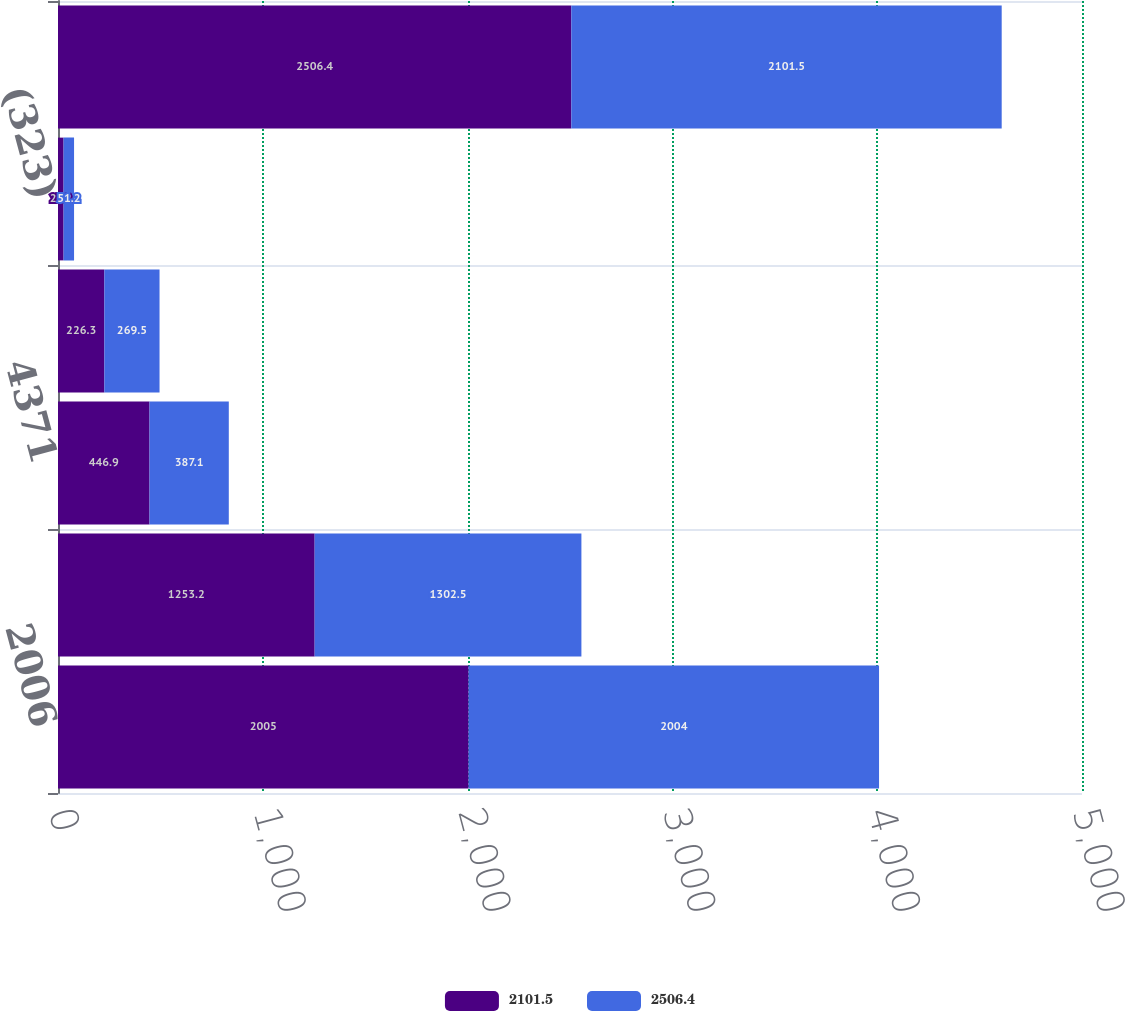<chart> <loc_0><loc_0><loc_500><loc_500><stacked_bar_chart><ecel><fcel>2006<fcel>12422<fcel>4371<fcel>2462<fcel>(323)<fcel>23106<nl><fcel>2101.5<fcel>2005<fcel>1253.2<fcel>446.9<fcel>226.3<fcel>27.2<fcel>2506.4<nl><fcel>2506.4<fcel>2004<fcel>1302.5<fcel>387.1<fcel>269.5<fcel>51.2<fcel>2101.5<nl></chart> 